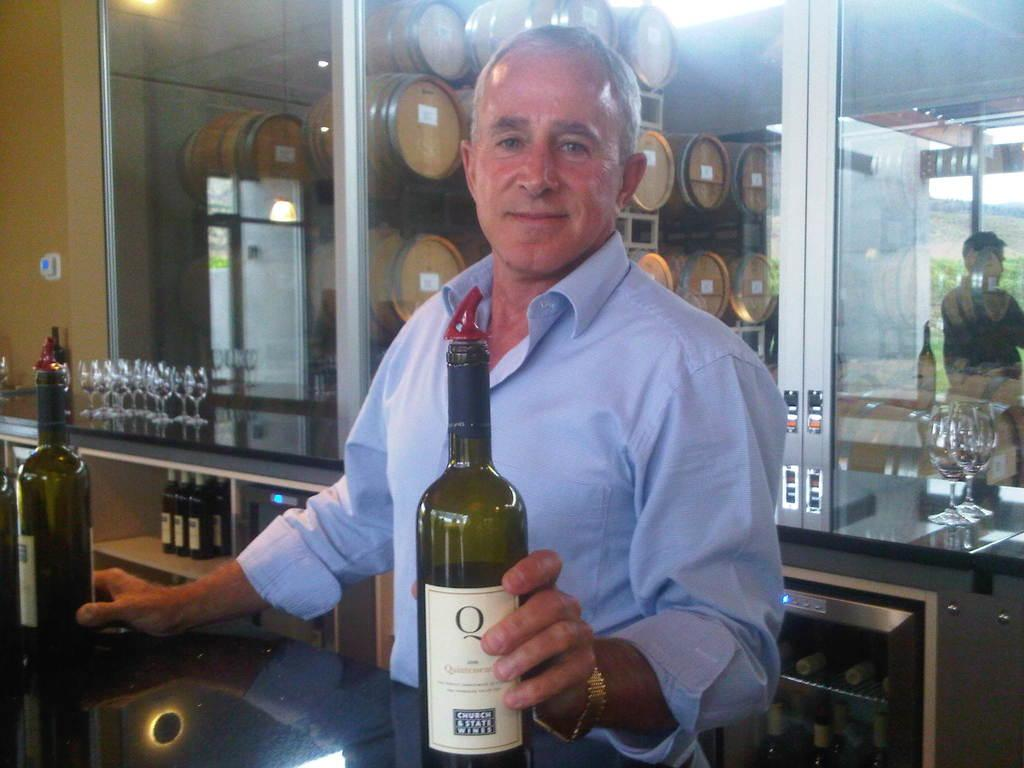Provide a one-sentence caption for the provided image. the word Q that is on a bottle. 